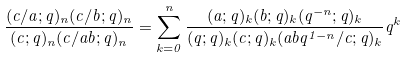<formula> <loc_0><loc_0><loc_500><loc_500>\frac { ( c / a ; q ) _ { n } ( c / b ; q ) _ { n } } { ( c ; q ) _ { n } ( c / a b ; q ) _ { n } } = \sum _ { k = 0 } ^ { n } \frac { ( a ; q ) _ { k } ( b ; q ) _ { k } ( q ^ { - n } ; q ) _ { k } } { ( q ; q ) _ { k } ( c ; q ) _ { k } ( a b q ^ { 1 - n } / c ; q ) _ { k } } q ^ { k }</formula> 